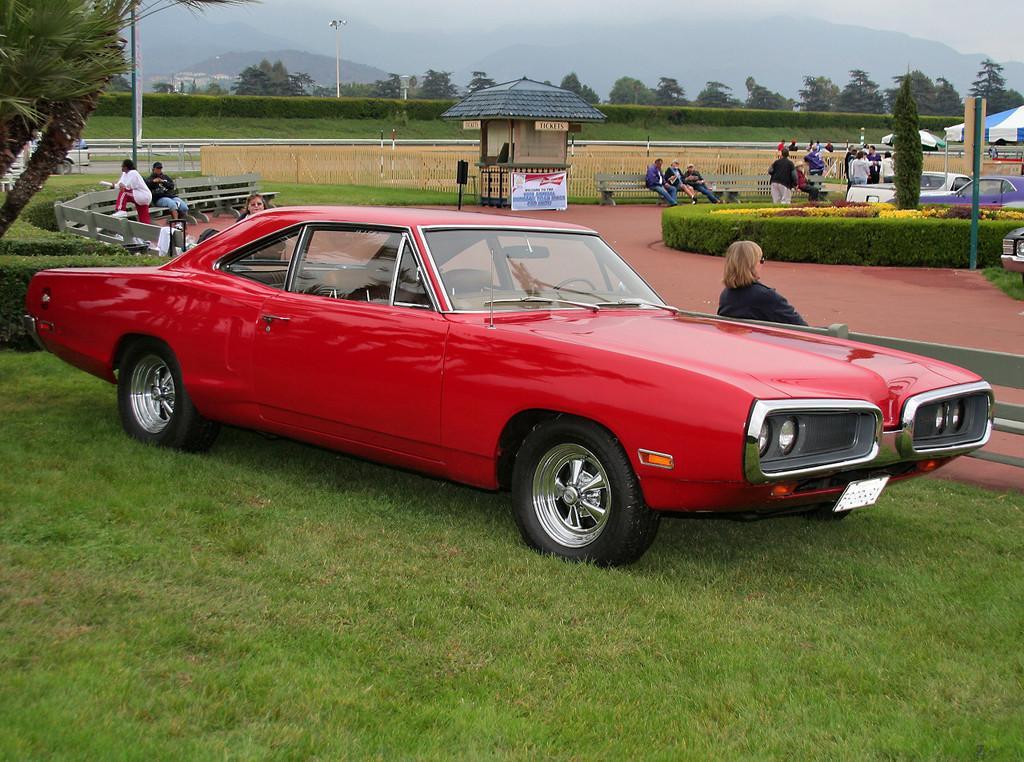Could you give a brief overview of what you see in this image? At the bottom of the image there is grass. In the middle of the image there are some vehicles. Behind the vehicles few people are sitting on benches. At the top of the image there are some poles and trees and hills and there are some tents. 